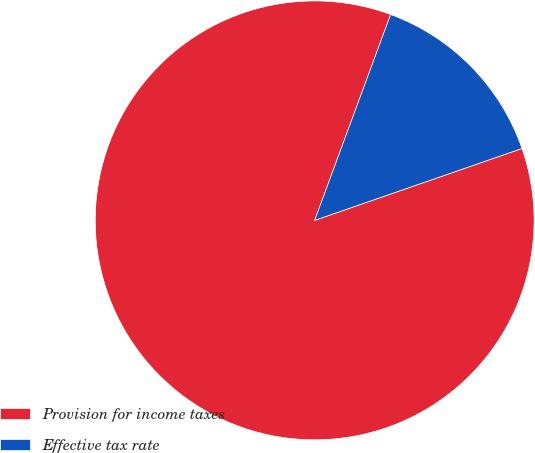Convert chart to OTSL. <chart><loc_0><loc_0><loc_500><loc_500><pie_chart><fcel>Provision for income taxes<fcel>Effective tax rate<nl><fcel>85.94%<fcel>14.06%<nl></chart> 